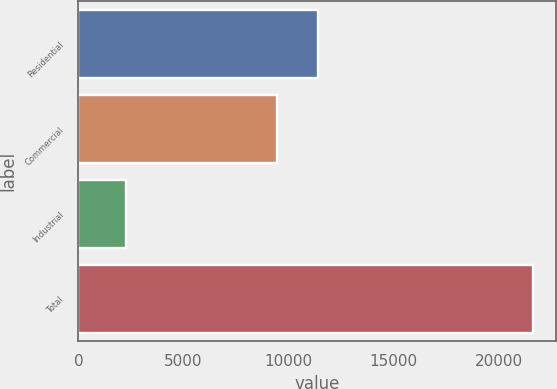<chart> <loc_0><loc_0><loc_500><loc_500><bar_chart><fcel>Residential<fcel>Commercial<fcel>Industrial<fcel>Total<nl><fcel>11397.8<fcel>9461<fcel>2249<fcel>21617<nl></chart> 